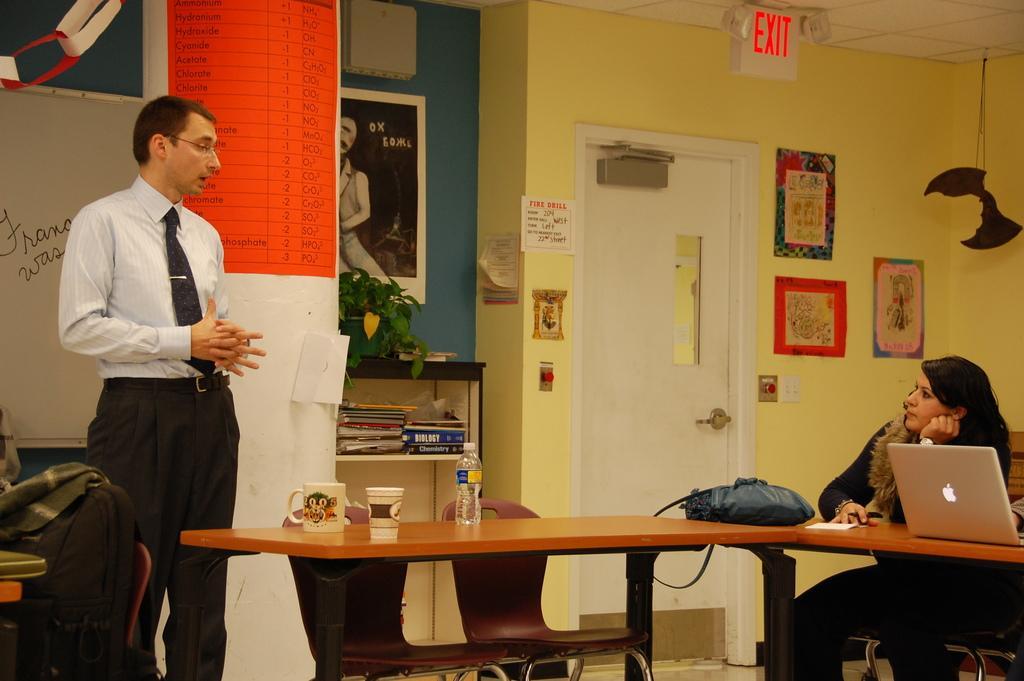In one or two sentences, can you explain what this image depicts? In this picture there are two people , the woman is sitting on the table with her laptop on the table. The man is talking with her. There is a door in the background above which there is EXIT written on the white box. We observe many posts attached to the wall and hangings. There is a whiteboard in the background. There are mugs on the table and a water bottle. 